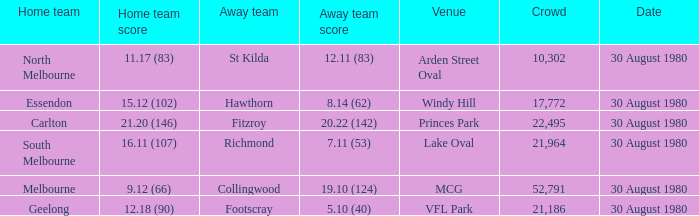Parse the full table. {'header': ['Home team', 'Home team score', 'Away team', 'Away team score', 'Venue', 'Crowd', 'Date'], 'rows': [['North Melbourne', '11.17 (83)', 'St Kilda', '12.11 (83)', 'Arden Street Oval', '10,302', '30 August 1980'], ['Essendon', '15.12 (102)', 'Hawthorn', '8.14 (62)', 'Windy Hill', '17,772', '30 August 1980'], ['Carlton', '21.20 (146)', 'Fitzroy', '20.22 (142)', 'Princes Park', '22,495', '30 August 1980'], ['South Melbourne', '16.11 (107)', 'Richmond', '7.11 (53)', 'Lake Oval', '21,964', '30 August 1980'], ['Melbourne', '9.12 (66)', 'Collingwood', '19.10 (124)', 'MCG', '52,791', '30 August 1980'], ['Geelong', '12.18 (90)', 'Footscray', '5.10 (40)', 'VFL Park', '21,186', '30 August 1980']]} How large was the audience when footscray was the away team? 21186.0. 